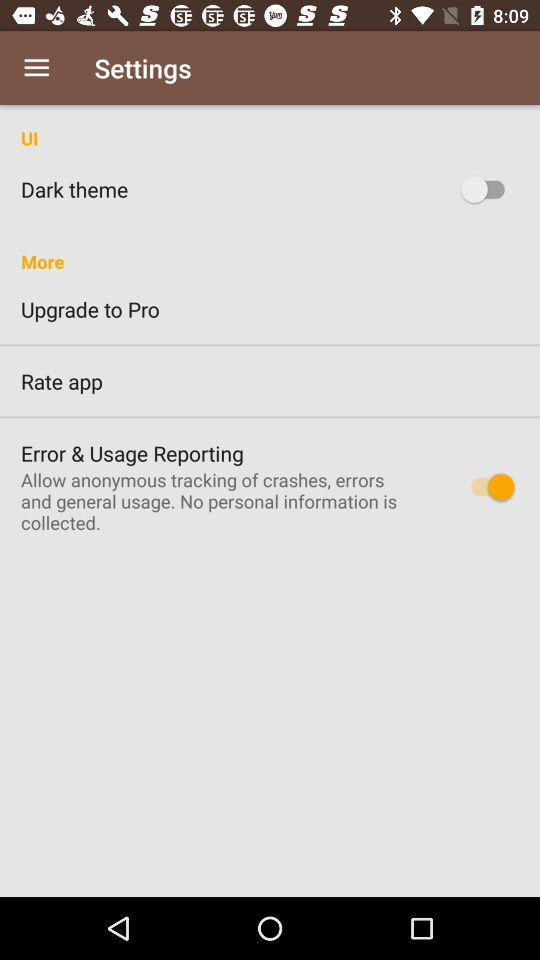What is the status of error and usage reporting? The status is on. 